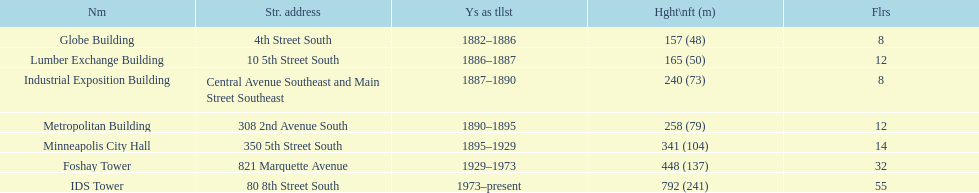How many floors does the foshay tower have? 32. 